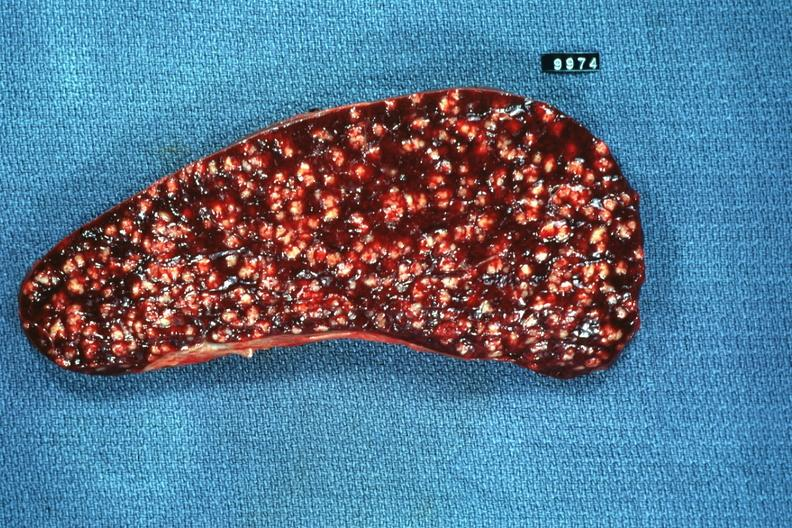s close-up excellent example of interosseous muscle atrophy present?
Answer the question using a single word or phrase. No 